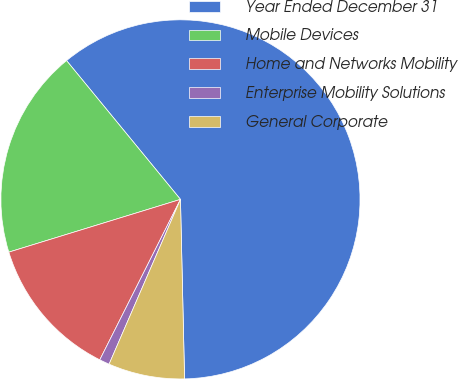Convert chart. <chart><loc_0><loc_0><loc_500><loc_500><pie_chart><fcel>Year Ended December 31<fcel>Mobile Devices<fcel>Home and Networks Mobility<fcel>Enterprise Mobility Solutions<fcel>General Corporate<nl><fcel>60.58%<fcel>18.81%<fcel>12.84%<fcel>0.91%<fcel>6.87%<nl></chart> 